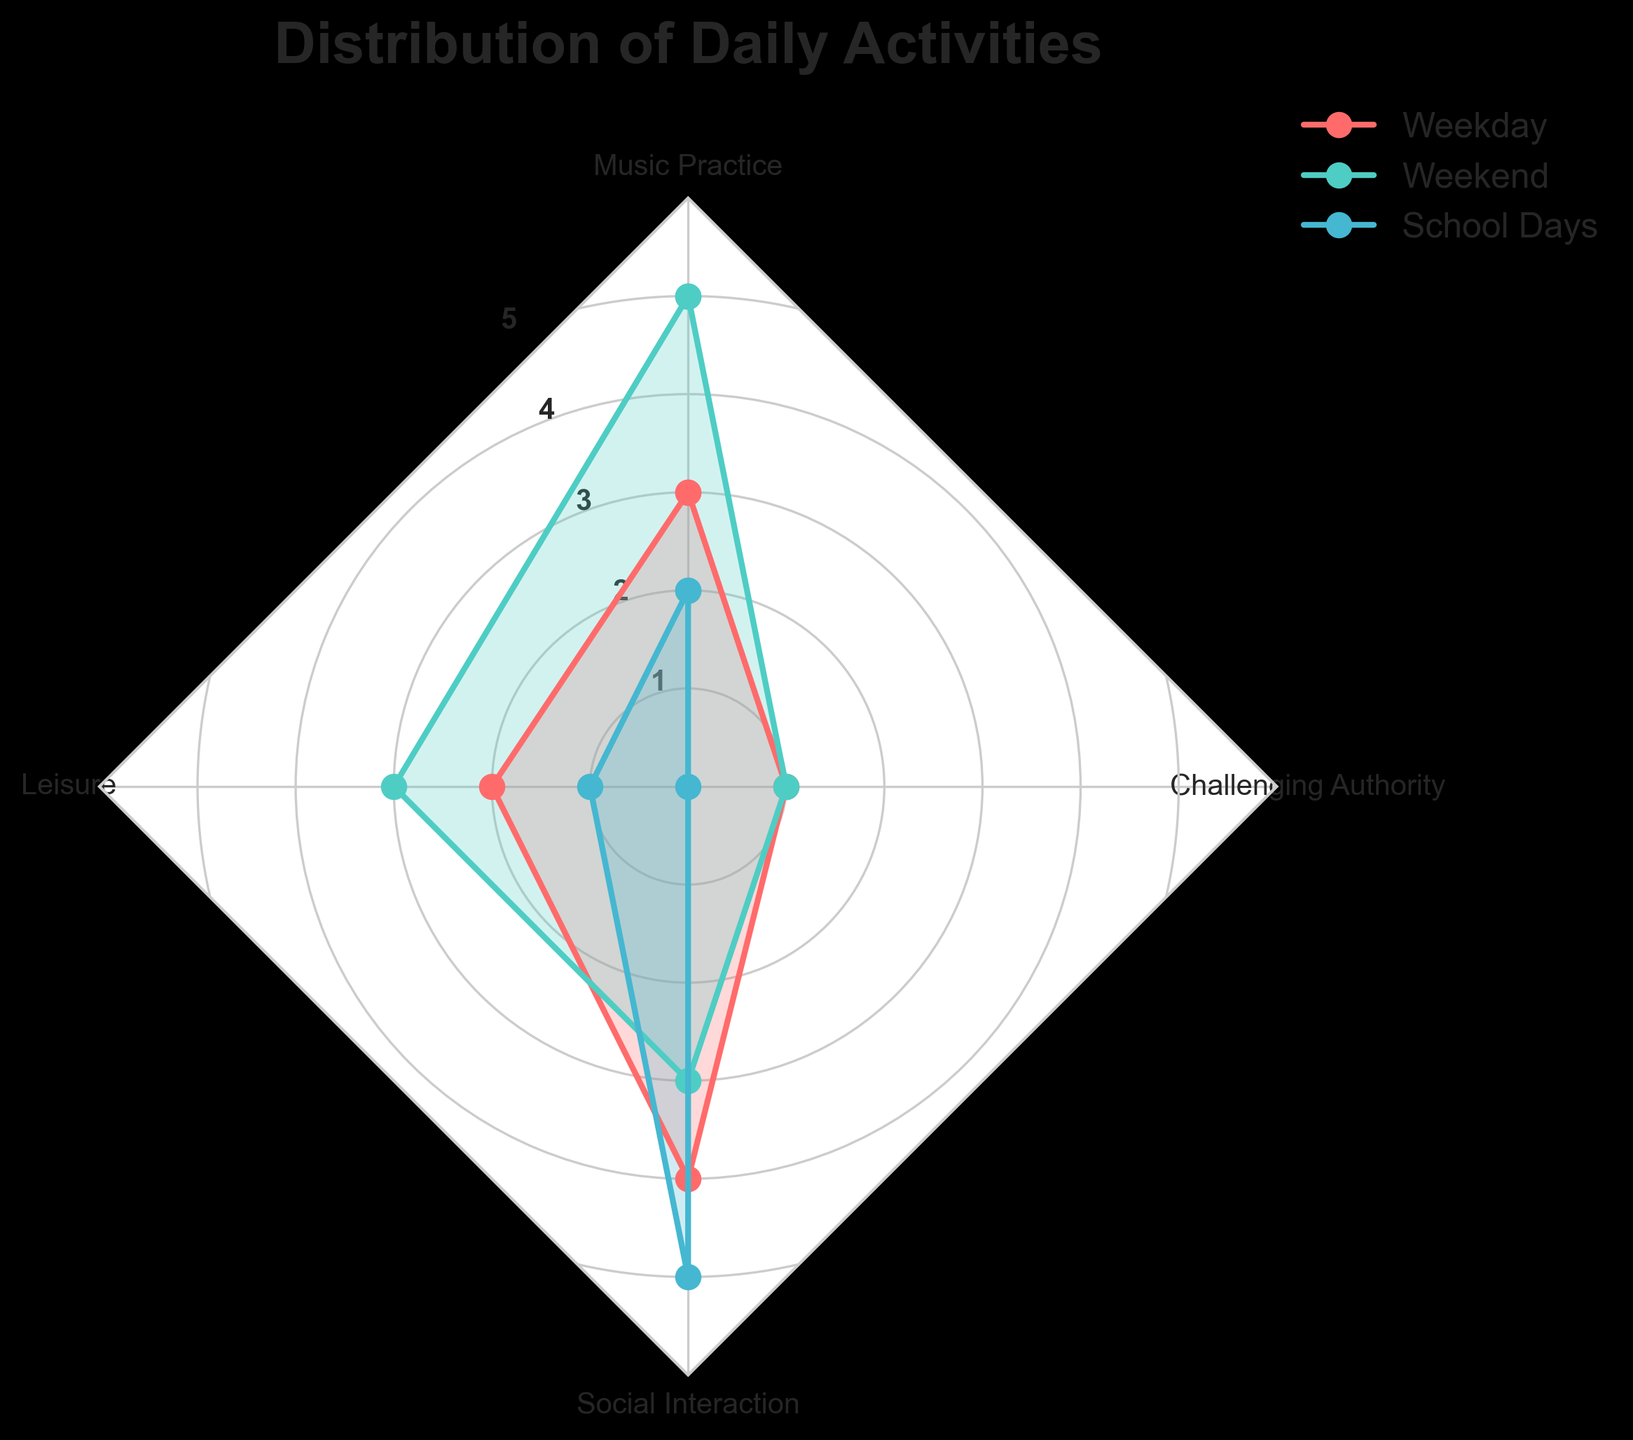What is the title of the radar chart? The title of the radar chart is displayed at the top of the figure. It is written in bold and large font to make it easily noticeable.
Answer: Distribution of Daily Activities How many groups are represented in the radar chart? Each group in the radar chart is represented by different colors with labels in the legend. Counting these unique labels reveals the number of groups.
Answer: 3 Which activity has the highest value for Social Interaction? By examining the Social Interaction axis, the segment that reaches the highest point corresponds to the highest value for this activity.
Answer: School Days What is the average value of Music Practice across all groups? Adding the values of Music Practice from Weekday, Weekend, and School Days, then dividing by the number of groups (3), gives the average. Calculation: (3+5+2)/3 = 10/3
Answer: 3.33 Compare the time spent on Leisure between Weekday and Weekend. Which one is greater? By looking at the Leisure axis, the points for Weekday and Weekend can be compared, where the segment that extends further from the center indicates a greater value.
Answer: Weekend What is the total time spent on Challenging Authority across all groups? Summing the values of Challenging Authority from Weekday, Weekend, and School Days provides the total time for this activity. Calculation: 1 + 1 + 0 = 2
Answer: 2 Identify the group with the least time spent on Music Practice. By finding the smallest value on the Music Practice axis among the groups, the corresponding group with the least time spent is identified.
Answer: School Days Which activity shows equal time spent during Weekdays and Weekends? Examining the values across the axes for each activity, the one with identical values for Weekday and Weekend is identified.
Answer: Challenging Authority On School Days, which activity has the maximum time spent? By examining the data points specifically for School Days, the largest value across all activities is identified for the maximum time spent.
Answer: Social Interaction 